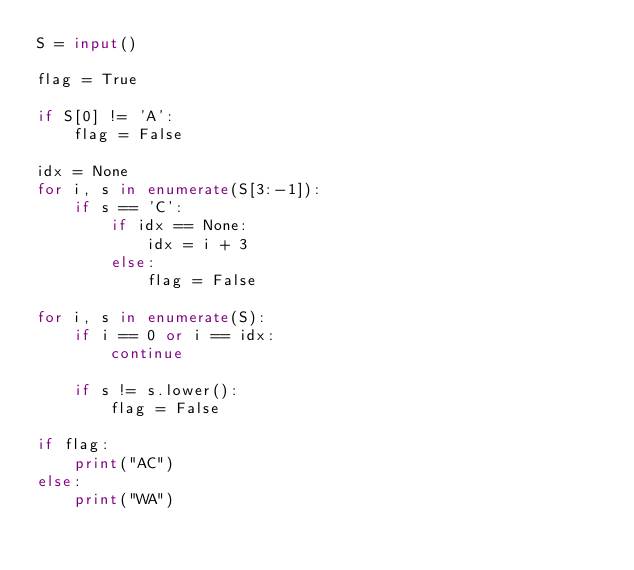<code> <loc_0><loc_0><loc_500><loc_500><_Python_>S = input()

flag = True

if S[0] != 'A':
    flag = False

idx = None
for i, s in enumerate(S[3:-1]):
    if s == 'C':
        if idx == None:
            idx = i + 3
        else:
            flag = False

for i, s in enumerate(S):
    if i == 0 or i == idx:
        continue

    if s != s.lower():
        flag = False

if flag:
    print("AC")
else:
    print("WA")</code> 